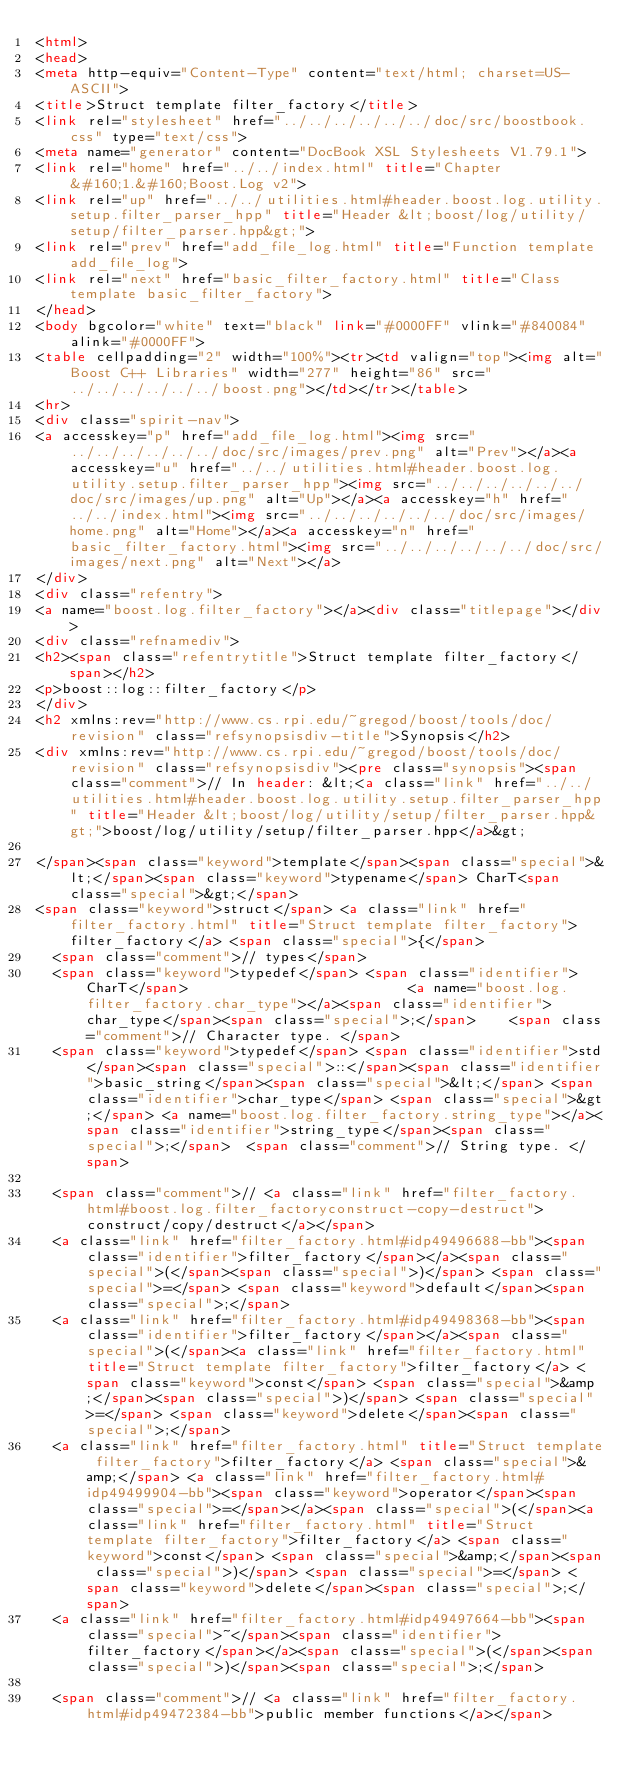Convert code to text. <code><loc_0><loc_0><loc_500><loc_500><_HTML_><html>
<head>
<meta http-equiv="Content-Type" content="text/html; charset=US-ASCII">
<title>Struct template filter_factory</title>
<link rel="stylesheet" href="../../../../../../doc/src/boostbook.css" type="text/css">
<meta name="generator" content="DocBook XSL Stylesheets V1.79.1">
<link rel="home" href="../../index.html" title="Chapter&#160;1.&#160;Boost.Log v2">
<link rel="up" href="../../utilities.html#header.boost.log.utility.setup.filter_parser_hpp" title="Header &lt;boost/log/utility/setup/filter_parser.hpp&gt;">
<link rel="prev" href="add_file_log.html" title="Function template add_file_log">
<link rel="next" href="basic_filter_factory.html" title="Class template basic_filter_factory">
</head>
<body bgcolor="white" text="black" link="#0000FF" vlink="#840084" alink="#0000FF">
<table cellpadding="2" width="100%"><tr><td valign="top"><img alt="Boost C++ Libraries" width="277" height="86" src="../../../../../../boost.png"></td></tr></table>
<hr>
<div class="spirit-nav">
<a accesskey="p" href="add_file_log.html"><img src="../../../../../../doc/src/images/prev.png" alt="Prev"></a><a accesskey="u" href="../../utilities.html#header.boost.log.utility.setup.filter_parser_hpp"><img src="../../../../../../doc/src/images/up.png" alt="Up"></a><a accesskey="h" href="../../index.html"><img src="../../../../../../doc/src/images/home.png" alt="Home"></a><a accesskey="n" href="basic_filter_factory.html"><img src="../../../../../../doc/src/images/next.png" alt="Next"></a>
</div>
<div class="refentry">
<a name="boost.log.filter_factory"></a><div class="titlepage"></div>
<div class="refnamediv">
<h2><span class="refentrytitle">Struct template filter_factory</span></h2>
<p>boost::log::filter_factory</p>
</div>
<h2 xmlns:rev="http://www.cs.rpi.edu/~gregod/boost/tools/doc/revision" class="refsynopsisdiv-title">Synopsis</h2>
<div xmlns:rev="http://www.cs.rpi.edu/~gregod/boost/tools/doc/revision" class="refsynopsisdiv"><pre class="synopsis"><span class="comment">// In header: &lt;<a class="link" href="../../utilities.html#header.boost.log.utility.setup.filter_parser_hpp" title="Header &lt;boost/log/utility/setup/filter_parser.hpp&gt;">boost/log/utility/setup/filter_parser.hpp</a>&gt;

</span><span class="keyword">template</span><span class="special">&lt;</span><span class="keyword">typename</span> CharT<span class="special">&gt;</span> 
<span class="keyword">struct</span> <a class="link" href="filter_factory.html" title="Struct template filter_factory">filter_factory</a> <span class="special">{</span>
  <span class="comment">// types</span>
  <span class="keyword">typedef</span> <span class="identifier">CharT</span>                          <a name="boost.log.filter_factory.char_type"></a><span class="identifier">char_type</span><span class="special">;</span>    <span class="comment">// Character type. </span>
  <span class="keyword">typedef</span> <span class="identifier">std</span><span class="special">::</span><span class="identifier">basic_string</span><span class="special">&lt;</span> <span class="identifier">char_type</span> <span class="special">&gt;</span> <a name="boost.log.filter_factory.string_type"></a><span class="identifier">string_type</span><span class="special">;</span>  <span class="comment">// String type. </span>

  <span class="comment">// <a class="link" href="filter_factory.html#boost.log.filter_factoryconstruct-copy-destruct">construct/copy/destruct</a></span>
  <a class="link" href="filter_factory.html#idp49496688-bb"><span class="identifier">filter_factory</span></a><span class="special">(</span><span class="special">)</span> <span class="special">=</span> <span class="keyword">default</span><span class="special">;</span>
  <a class="link" href="filter_factory.html#idp49498368-bb"><span class="identifier">filter_factory</span></a><span class="special">(</span><a class="link" href="filter_factory.html" title="Struct template filter_factory">filter_factory</a> <span class="keyword">const</span> <span class="special">&amp;</span><span class="special">)</span> <span class="special">=</span> <span class="keyword">delete</span><span class="special">;</span>
  <a class="link" href="filter_factory.html" title="Struct template filter_factory">filter_factory</a> <span class="special">&amp;</span> <a class="link" href="filter_factory.html#idp49499904-bb"><span class="keyword">operator</span><span class="special">=</span></a><span class="special">(</span><a class="link" href="filter_factory.html" title="Struct template filter_factory">filter_factory</a> <span class="keyword">const</span> <span class="special">&amp;</span><span class="special">)</span> <span class="special">=</span> <span class="keyword">delete</span><span class="special">;</span>
  <a class="link" href="filter_factory.html#idp49497664-bb"><span class="special">~</span><span class="identifier">filter_factory</span></a><span class="special">(</span><span class="special">)</span><span class="special">;</span>

  <span class="comment">// <a class="link" href="filter_factory.html#idp49472384-bb">public member functions</a></span></code> 